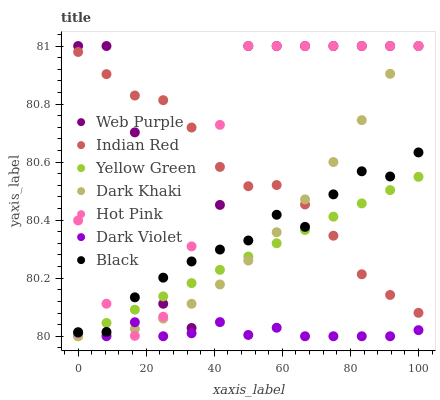Does Dark Violet have the minimum area under the curve?
Answer yes or no. Yes. Does Web Purple have the maximum area under the curve?
Answer yes or no. Yes. Does Hot Pink have the minimum area under the curve?
Answer yes or no. No. Does Hot Pink have the maximum area under the curve?
Answer yes or no. No. Is Yellow Green the smoothest?
Answer yes or no. Yes. Is Web Purple the roughest?
Answer yes or no. Yes. Is Hot Pink the smoothest?
Answer yes or no. No. Is Hot Pink the roughest?
Answer yes or no. No. Does Yellow Green have the lowest value?
Answer yes or no. Yes. Does Hot Pink have the lowest value?
Answer yes or no. No. Does Web Purple have the highest value?
Answer yes or no. Yes. Does Dark Violet have the highest value?
Answer yes or no. No. Is Dark Violet less than Indian Red?
Answer yes or no. Yes. Is Web Purple greater than Dark Violet?
Answer yes or no. Yes. Does Indian Red intersect Hot Pink?
Answer yes or no. Yes. Is Indian Red less than Hot Pink?
Answer yes or no. No. Is Indian Red greater than Hot Pink?
Answer yes or no. No. Does Dark Violet intersect Indian Red?
Answer yes or no. No. 